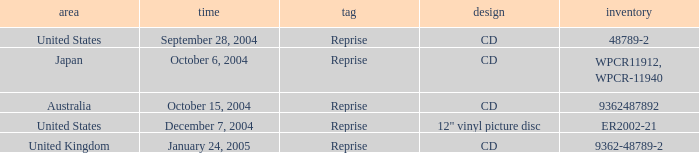Name the region for december 7, 2004 United States. 